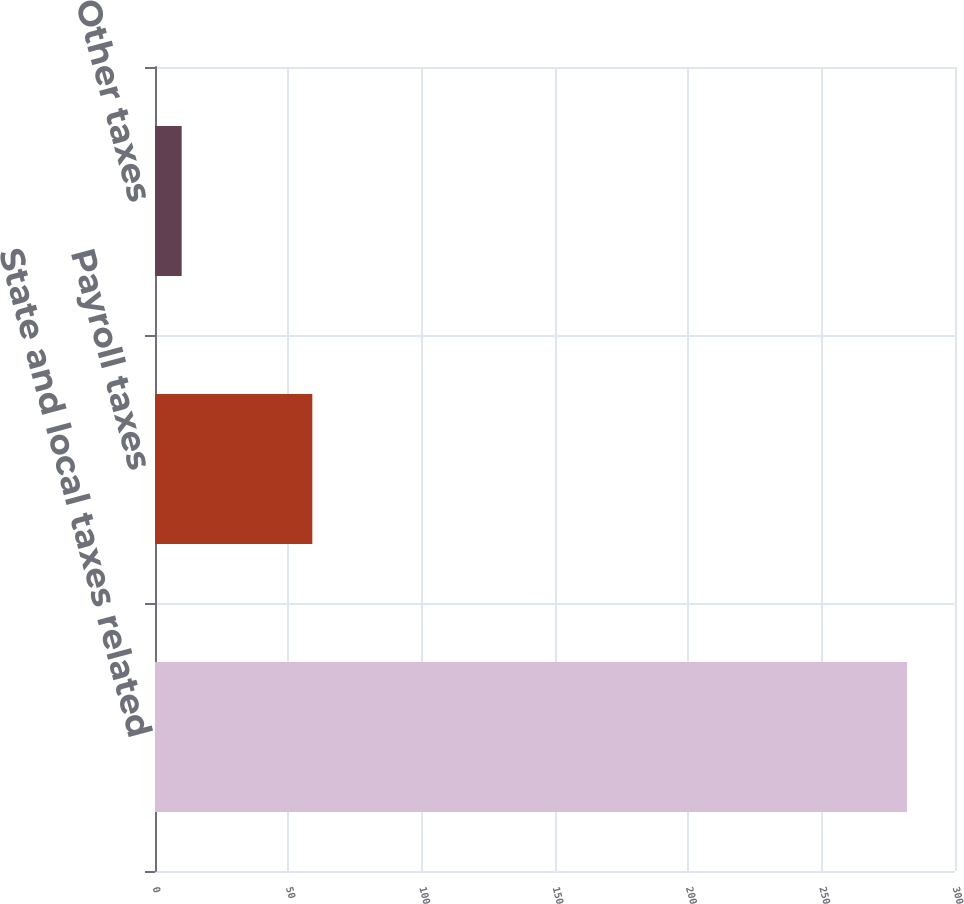Convert chart. <chart><loc_0><loc_0><loc_500><loc_500><bar_chart><fcel>State and local taxes related<fcel>Payroll taxes<fcel>Other taxes<nl><fcel>282<fcel>59<fcel>10<nl></chart> 